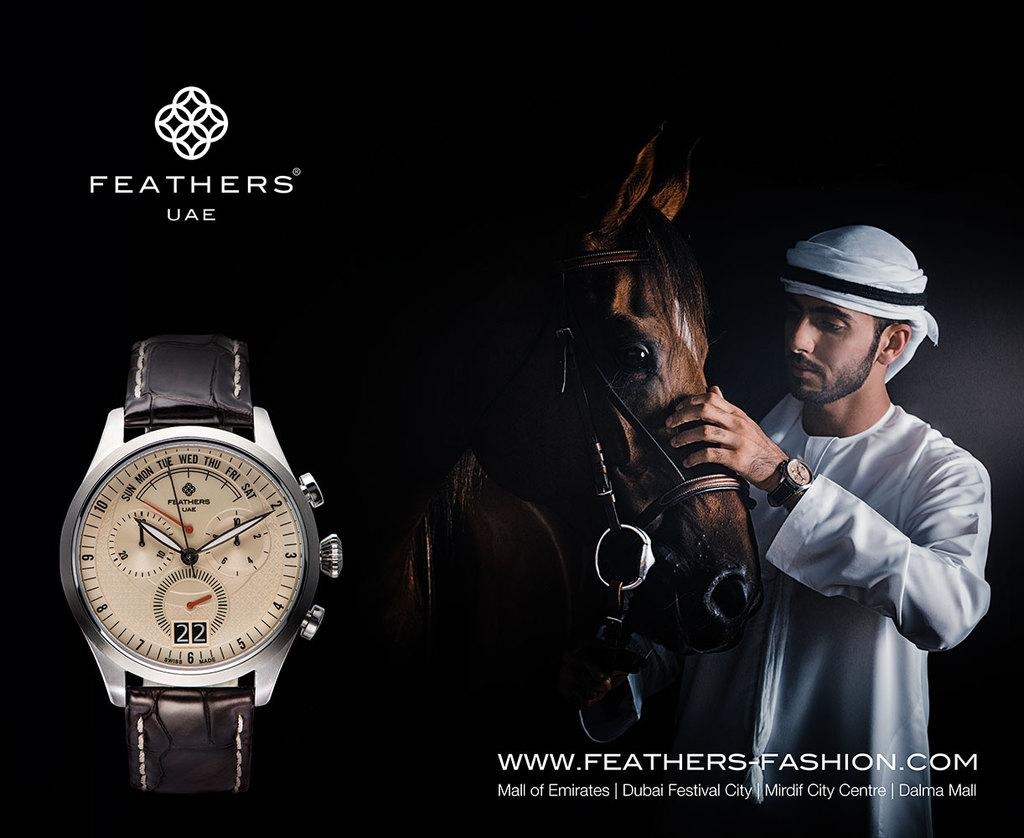Who is the main subject in the image? There is a man in the image. What is the man wearing? The man is wearing white attire. What is the man doing in the image? The man has his hand on a horse. Can you identify any other objects in the image? Yes, there is a watch in the image. How is the man's mother involved in the scene depicted in the image? There is no mention of the man's mother in the image, so we cannot determine her involvement in the scene. 